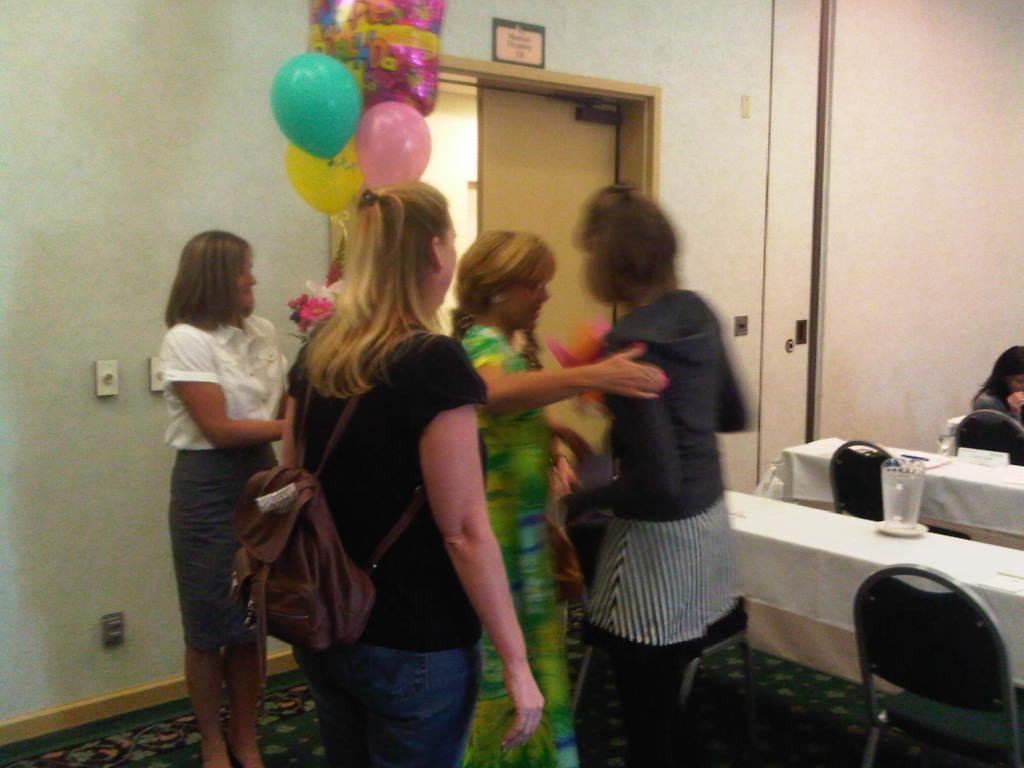Who is present in the image? There are women standing in the image. What can be seen in the middle of the image? There are balloons in the middle of the image. What furniture is located on the left side of the room in the image? There is a table with chairs on the left side of the room in the image. What type of quartz is used to decorate the table in the image? There is no quartz present in the image; it features women standing near balloons and a table with chairs. What achievements have the women in the image accomplished? The image does not provide information about the women's achievements, so it cannot be determined from the image. 